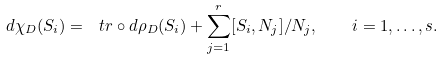Convert formula to latex. <formula><loc_0><loc_0><loc_500><loc_500>d \chi _ { D } ( S _ { i } ) = \ t r \circ d \rho _ { D } ( S _ { i } ) + \sum _ { j = 1 } ^ { r } [ S _ { i } , N _ { j } ] / N _ { j } , \quad i = 1 , \dots , s .</formula> 